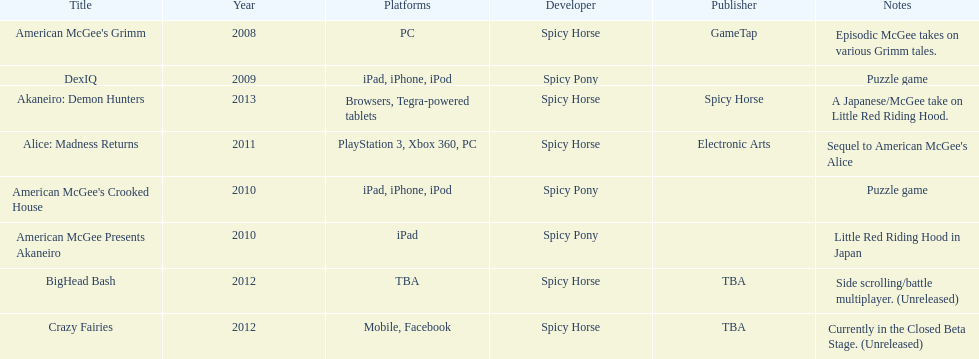On this chart, what platform is associated with the last title mentioned? Browsers, Tegra-powered tablets. 